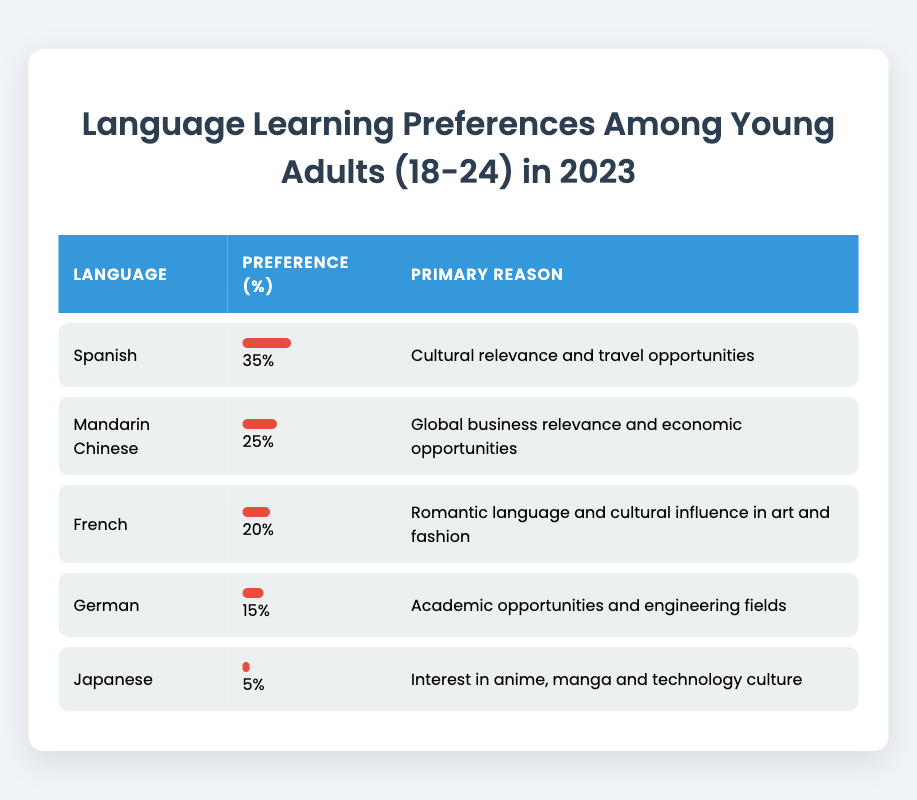What is the percentage preference for learning Spanish among young adults aged 18-24? The table clearly states that the preference percentage for Spanish is listed under the respective row, which shows 35%.
Answer: 35% Which language has the lowest preference percentage? By examining the "Preference (%)" column in the table, we find that Japanese has the lowest percentage, at 5%.
Answer: Japanese How much higher is the preference for Mandarin Chinese compared to German? To find this difference, we subtract the preference percentage of German (15%) from that of Mandarin Chinese (25%). Thus, 25% - 15% = 10%.
Answer: 10% Is the primary reason for learning French related to its cultural influence in art? The primary reason listed for learning French is indeed "Romantic language and cultural influence in art and fashion," indicating that this statement is true.
Answer: Yes If a young adult wanted to learn a language for travel opportunities, which language should they choose based on the table? The table lists Spanish as the language with a primary reason of "Cultural relevance and travel opportunities." This suggests that it is the best choice for travel motivations.
Answer: Spanish What is the total preference percentage for all languages combined? By adding the individual preference percentages (35 + 25 + 20 + 15 + 5), we get 100%. Thus, the total preference remains consistent at 100%.
Answer: 100% Which language has the highest preference percentage among the listed languages? The table's first row shows that Spanish has the highest preference at 35%, making it the highest amongst the languages listed.
Answer: Spanish How many languages have a preference percentage of 20% or higher? By examining the table, we see Spanish (35%), Mandarin Chinese (25%), and French (20%) all possess preference percentages of 20% or higher. This sums up to three languages.
Answer: 3 